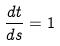<formula> <loc_0><loc_0><loc_500><loc_500>\frac { d t } { d s } = 1</formula> 